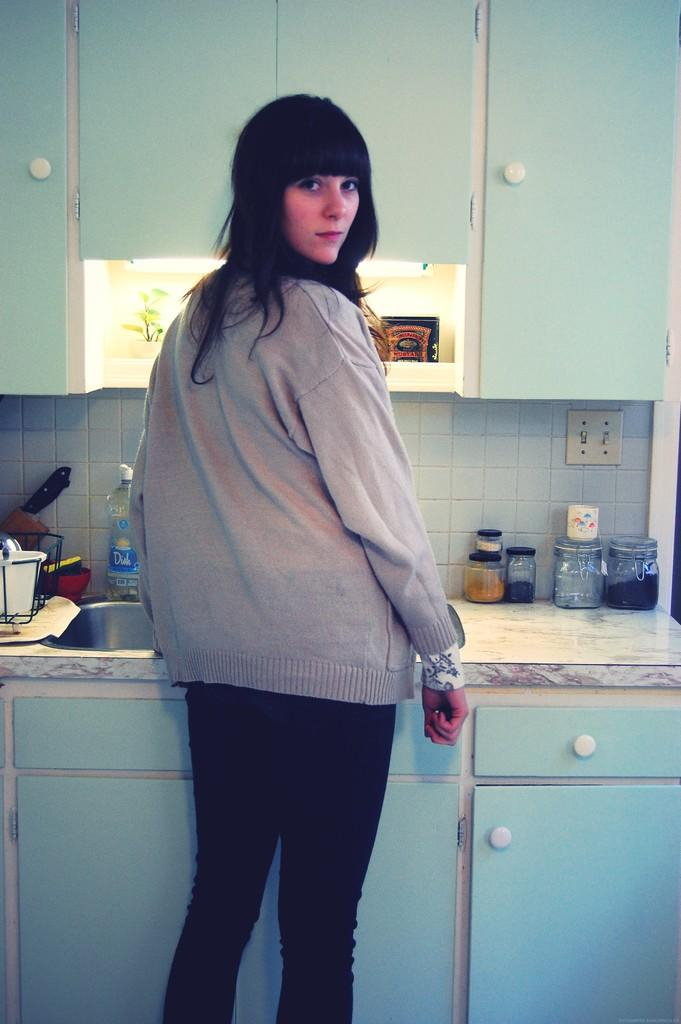What is the main subject of the image? There is a woman standing in the image. Can you describe what the woman is wearing? The woman is wearing clothes. What can be seen in the image besides the woman? There is a wash basin, a water bottle, a knife, jar bottles, a cupboard, and a plant in the image. What statement is being made by the plant in the image? Plants do not make statements; they are living organisms that do not have the ability to communicate through language. 